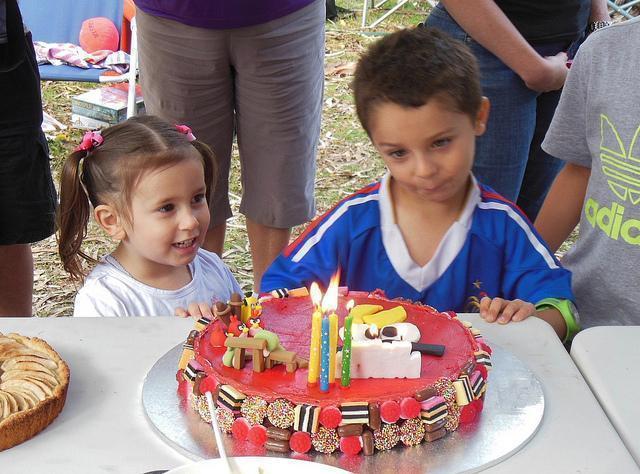When will this girl be old enough for Kindergarten?
Make your selection from the four choices given to correctly answer the question.
Options: 3 years, 1 year, 2 years, this year. 1 year. 